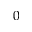Convert formula to latex. <formula><loc_0><loc_0><loc_500><loc_500>0</formula> 